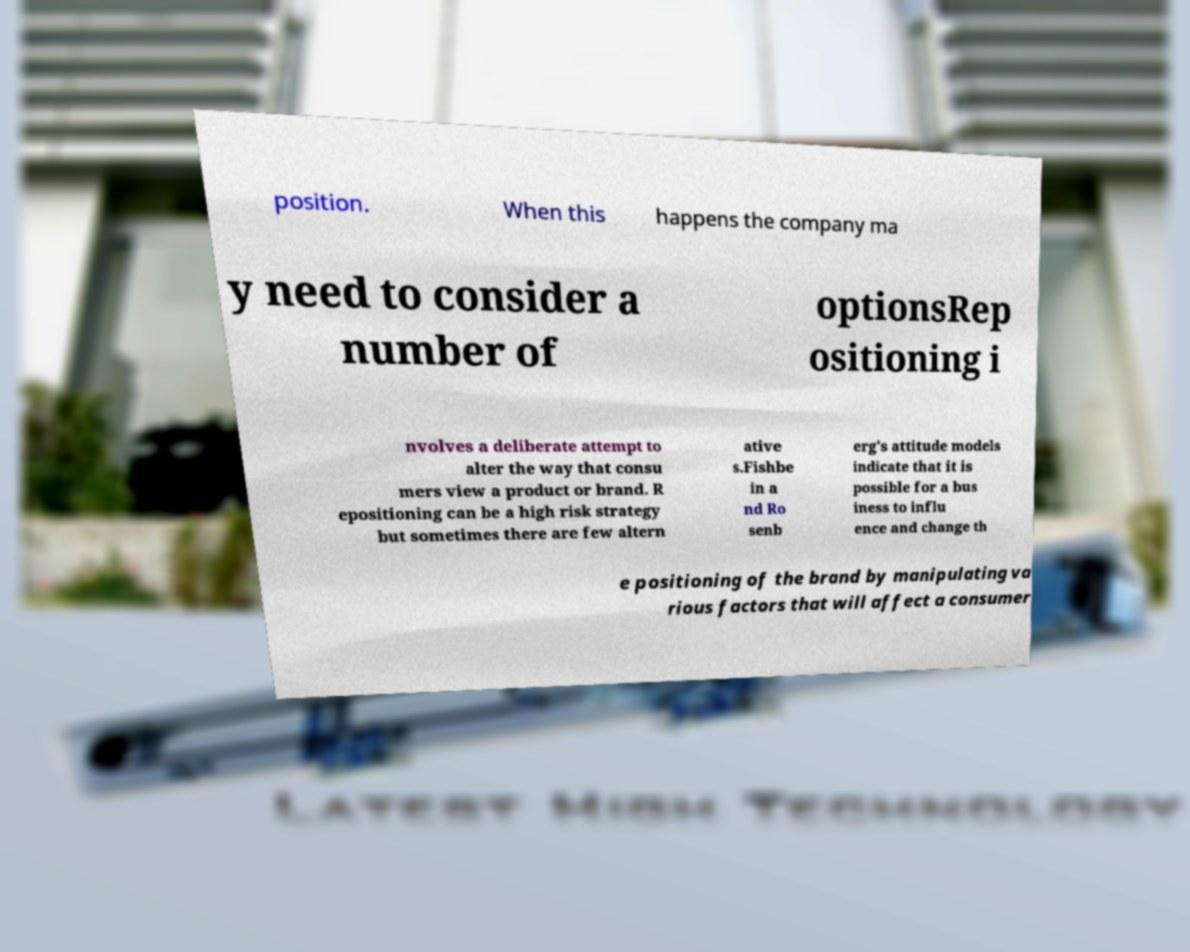There's text embedded in this image that I need extracted. Can you transcribe it verbatim? position. When this happens the company ma y need to consider a number of optionsRep ositioning i nvolves a deliberate attempt to alter the way that consu mers view a product or brand. R epositioning can be a high risk strategy but sometimes there are few altern ative s.Fishbe in a nd Ro senb erg's attitude models indicate that it is possible for a bus iness to influ ence and change th e positioning of the brand by manipulating va rious factors that will affect a consumer 